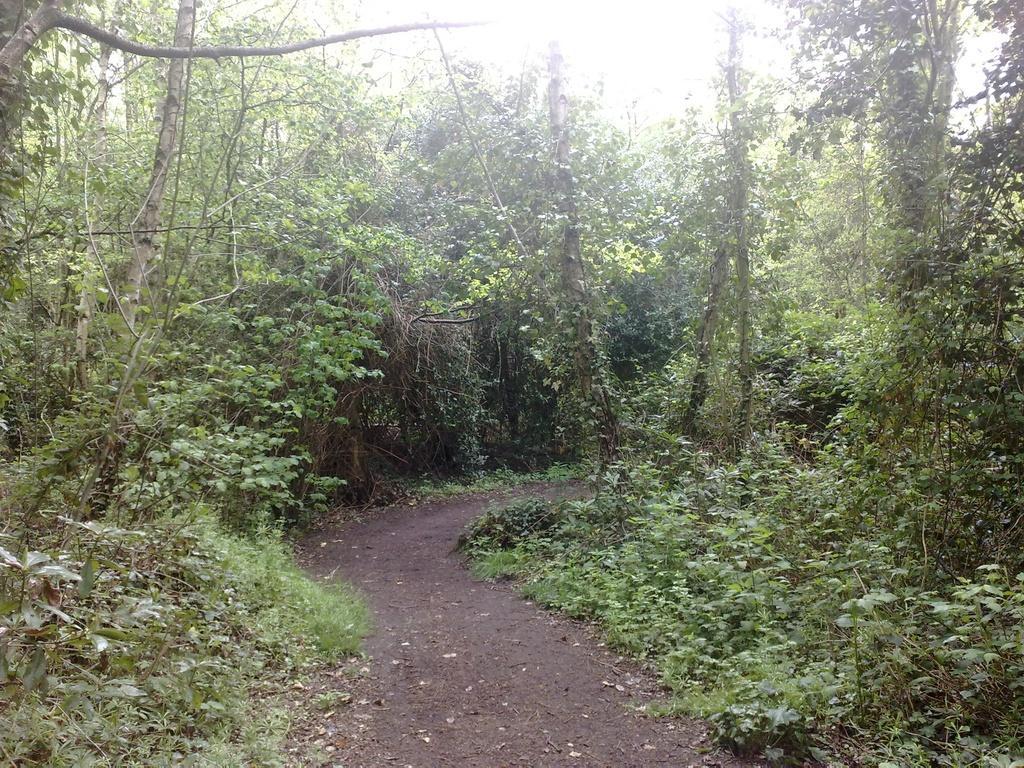Describe this image in one or two sentences. In this image we can see a many trees and a plants. There is bright sunshine at the top center of the image. 